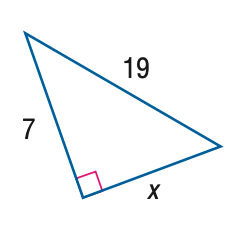Answer the mathemtical geometry problem and directly provide the correct option letter.
Question: Find x.
Choices: A: 7 B: 2 \sqrt { 78 } C: 19 D: \sqrt { 410 } B 